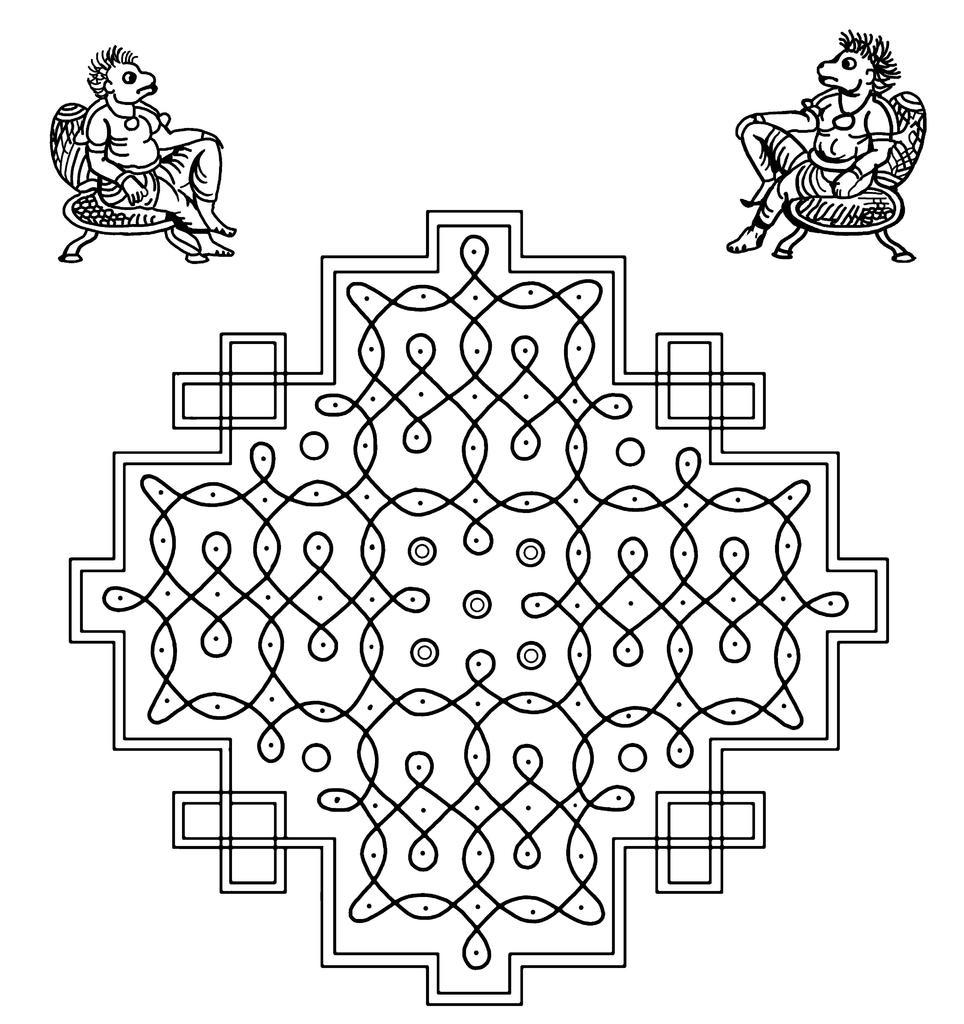What is the main subject of the image? The main subject of the image is an art piece. Can you describe the characters in the art piece? There are two cartoon characters in the image. What color scheme is used in the image? The color of the image is black and white. What type of stocking is the horse wearing in the image? There is no horse or stocking present in the image; it features an art piece with two cartoon characters. What is the source of humor in the image? The image does not contain any humor or comedic elements; it is an art piece with two cartoon characters. 